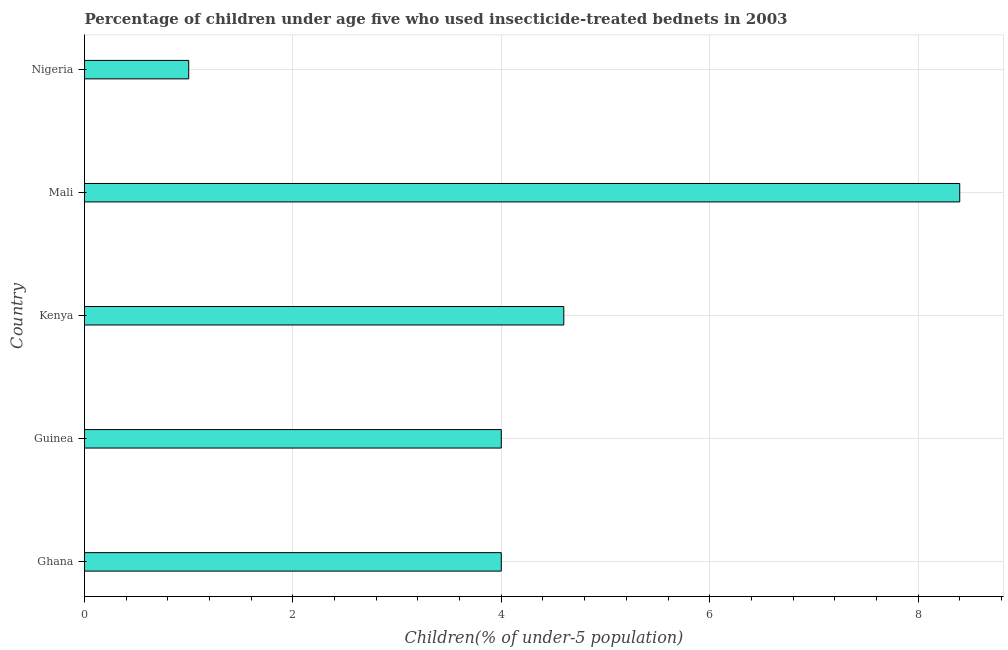Does the graph contain grids?
Your answer should be compact. Yes. What is the title of the graph?
Keep it short and to the point. Percentage of children under age five who used insecticide-treated bednets in 2003. What is the label or title of the X-axis?
Your response must be concise. Children(% of under-5 population). What is the percentage of children who use of insecticide-treated bed nets in Guinea?
Give a very brief answer. 4. Across all countries, what is the maximum percentage of children who use of insecticide-treated bed nets?
Ensure brevity in your answer.  8.4. In which country was the percentage of children who use of insecticide-treated bed nets maximum?
Ensure brevity in your answer.  Mali. In which country was the percentage of children who use of insecticide-treated bed nets minimum?
Offer a terse response. Nigeria. What is the sum of the percentage of children who use of insecticide-treated bed nets?
Ensure brevity in your answer.  22. What is the difference between the percentage of children who use of insecticide-treated bed nets in Kenya and Nigeria?
Keep it short and to the point. 3.6. What is the average percentage of children who use of insecticide-treated bed nets per country?
Provide a short and direct response. 4.4. What is the median percentage of children who use of insecticide-treated bed nets?
Provide a short and direct response. 4. In how many countries, is the percentage of children who use of insecticide-treated bed nets greater than 1.6 %?
Offer a very short reply. 4. What is the ratio of the percentage of children who use of insecticide-treated bed nets in Kenya to that in Nigeria?
Offer a very short reply. 4.6. Is the sum of the percentage of children who use of insecticide-treated bed nets in Kenya and Nigeria greater than the maximum percentage of children who use of insecticide-treated bed nets across all countries?
Give a very brief answer. No. Are all the bars in the graph horizontal?
Offer a terse response. Yes. How many countries are there in the graph?
Give a very brief answer. 5. What is the difference between two consecutive major ticks on the X-axis?
Offer a very short reply. 2. Are the values on the major ticks of X-axis written in scientific E-notation?
Your response must be concise. No. What is the Children(% of under-5 population) in Ghana?
Make the answer very short. 4. What is the Children(% of under-5 population) of Guinea?
Make the answer very short. 4. What is the Children(% of under-5 population) of Mali?
Ensure brevity in your answer.  8.4. What is the Children(% of under-5 population) of Nigeria?
Your answer should be very brief. 1. What is the difference between the Children(% of under-5 population) in Ghana and Guinea?
Ensure brevity in your answer.  0. What is the difference between the Children(% of under-5 population) in Ghana and Kenya?
Offer a terse response. -0.6. What is the difference between the Children(% of under-5 population) in Ghana and Nigeria?
Provide a short and direct response. 3. What is the difference between the Children(% of under-5 population) in Guinea and Kenya?
Provide a short and direct response. -0.6. What is the difference between the Children(% of under-5 population) in Guinea and Mali?
Give a very brief answer. -4.4. What is the ratio of the Children(% of under-5 population) in Ghana to that in Guinea?
Ensure brevity in your answer.  1. What is the ratio of the Children(% of under-5 population) in Ghana to that in Kenya?
Make the answer very short. 0.87. What is the ratio of the Children(% of under-5 population) in Ghana to that in Mali?
Your response must be concise. 0.48. What is the ratio of the Children(% of under-5 population) in Guinea to that in Kenya?
Provide a succinct answer. 0.87. What is the ratio of the Children(% of under-5 population) in Guinea to that in Mali?
Your answer should be very brief. 0.48. What is the ratio of the Children(% of under-5 population) in Kenya to that in Mali?
Your answer should be compact. 0.55. What is the ratio of the Children(% of under-5 population) in Kenya to that in Nigeria?
Keep it short and to the point. 4.6. 